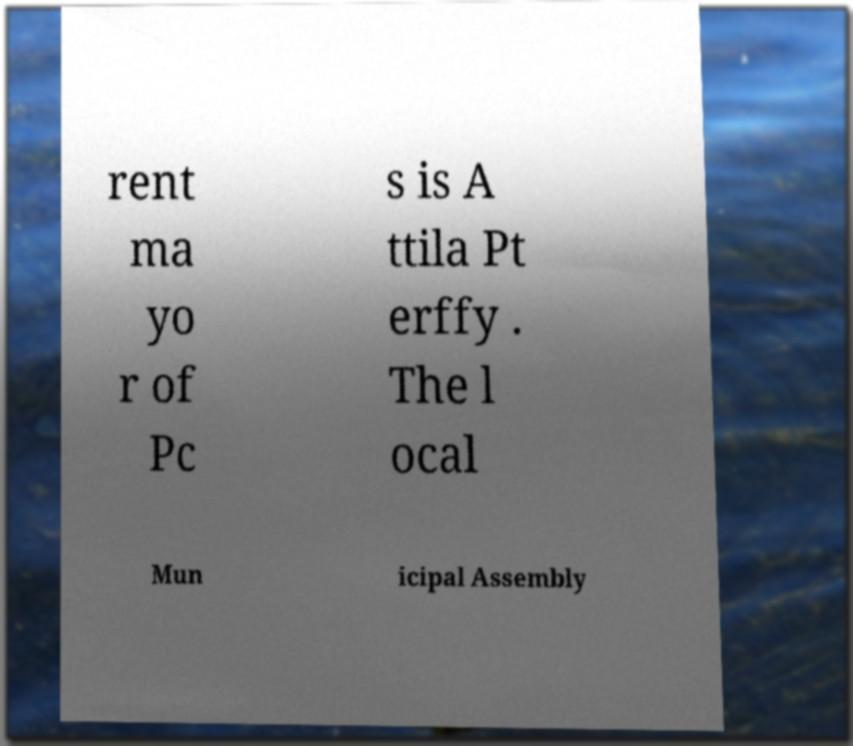What messages or text are displayed in this image? I need them in a readable, typed format. rent ma yo r of Pc s is A ttila Pt erffy . The l ocal Mun icipal Assembly 